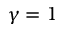<formula> <loc_0><loc_0><loc_500><loc_500>\gamma = 1</formula> 